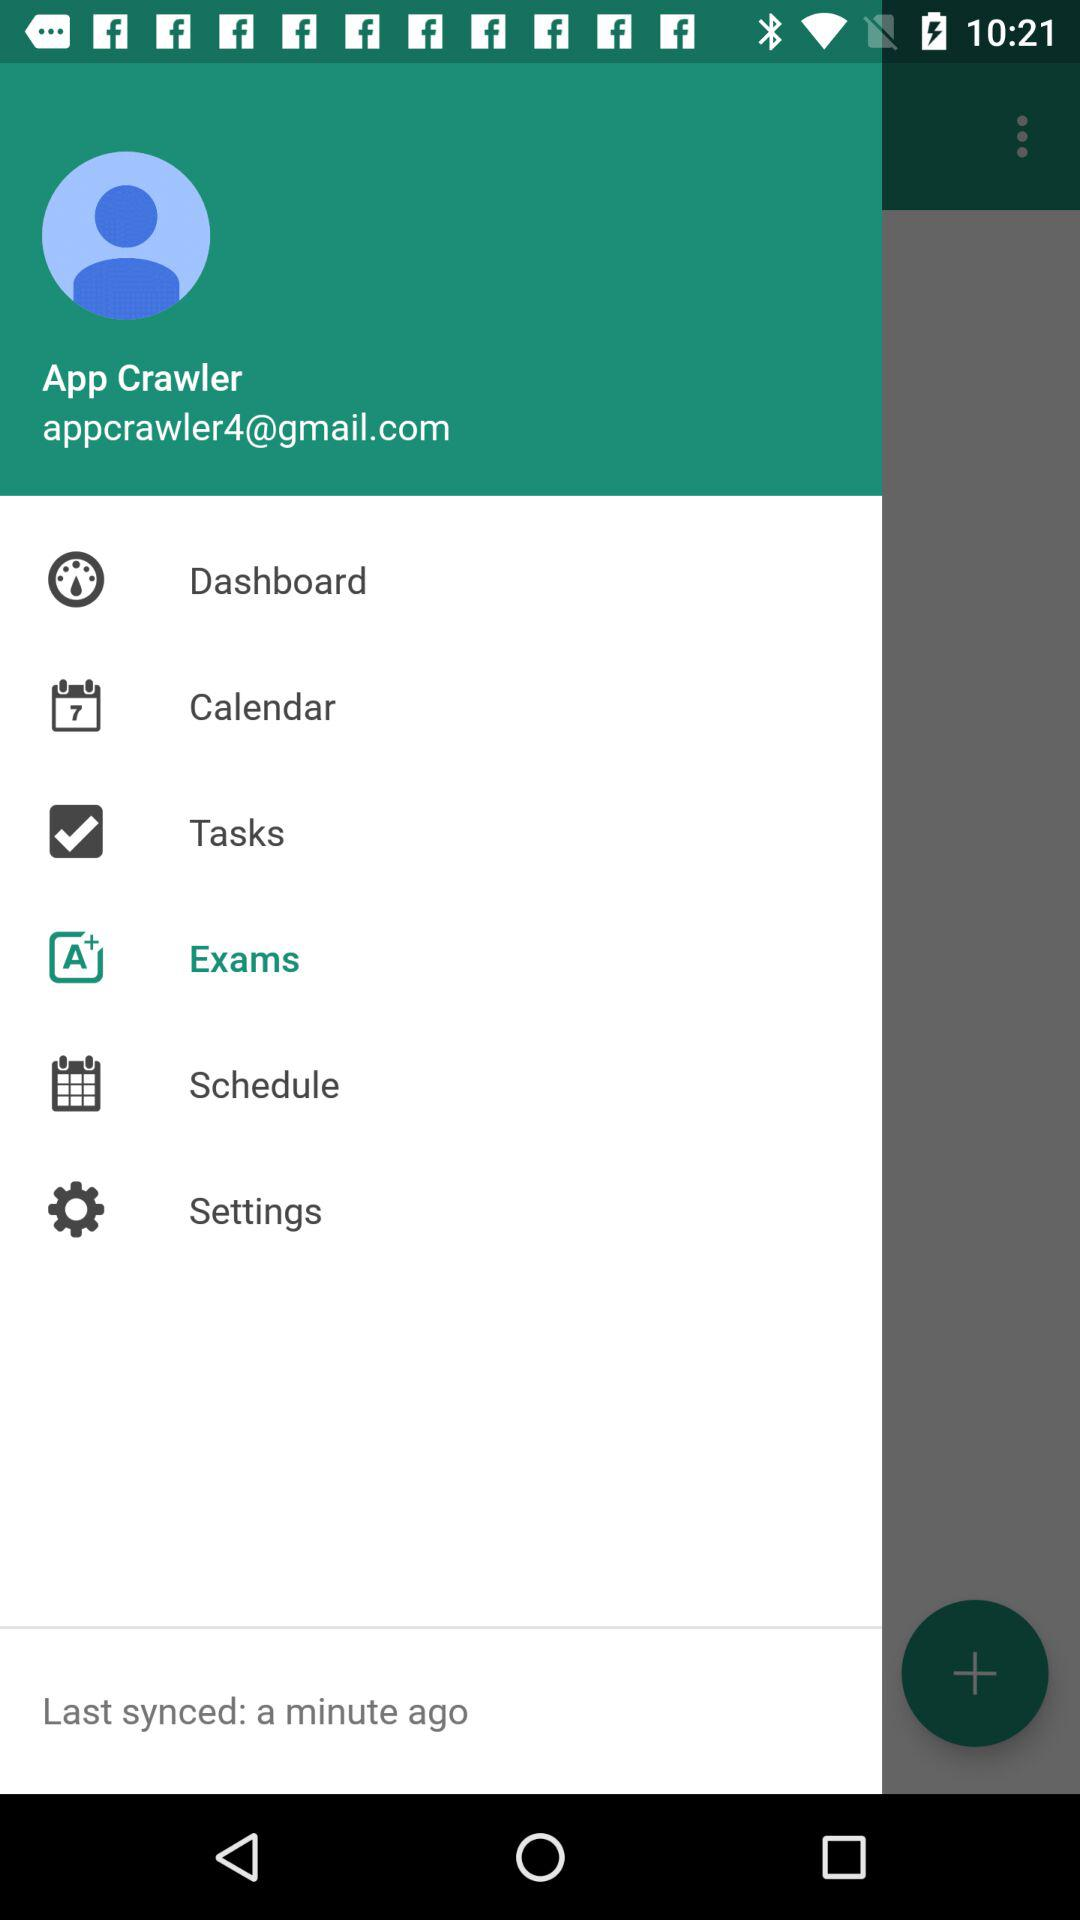How many minutes ago was the last synced done? The last sync was done "a minute ago". 